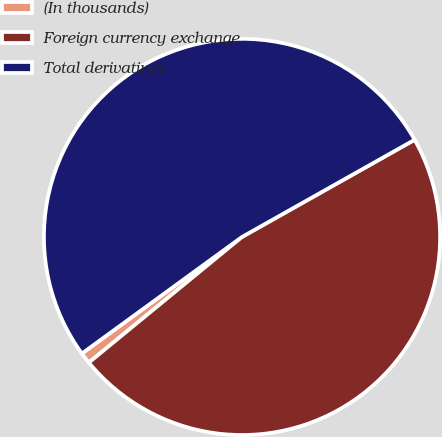Convert chart to OTSL. <chart><loc_0><loc_0><loc_500><loc_500><pie_chart><fcel>(In thousands)<fcel>Foreign currency exchange<fcel>Total derivatives<nl><fcel>0.92%<fcel>47.22%<fcel>51.85%<nl></chart> 